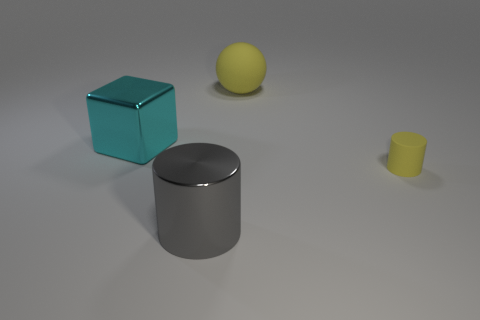Subtract 2 cylinders. How many cylinders are left? 0 Add 3 tiny yellow metal balls. How many objects exist? 7 Subtract all green blocks. How many cyan cylinders are left? 0 Subtract all cyan things. Subtract all large spheres. How many objects are left? 2 Add 1 matte things. How many matte things are left? 3 Add 1 red metallic cylinders. How many red metallic cylinders exist? 1 Subtract 1 yellow spheres. How many objects are left? 3 Subtract all blocks. How many objects are left? 3 Subtract all gray balls. Subtract all brown cylinders. How many balls are left? 1 